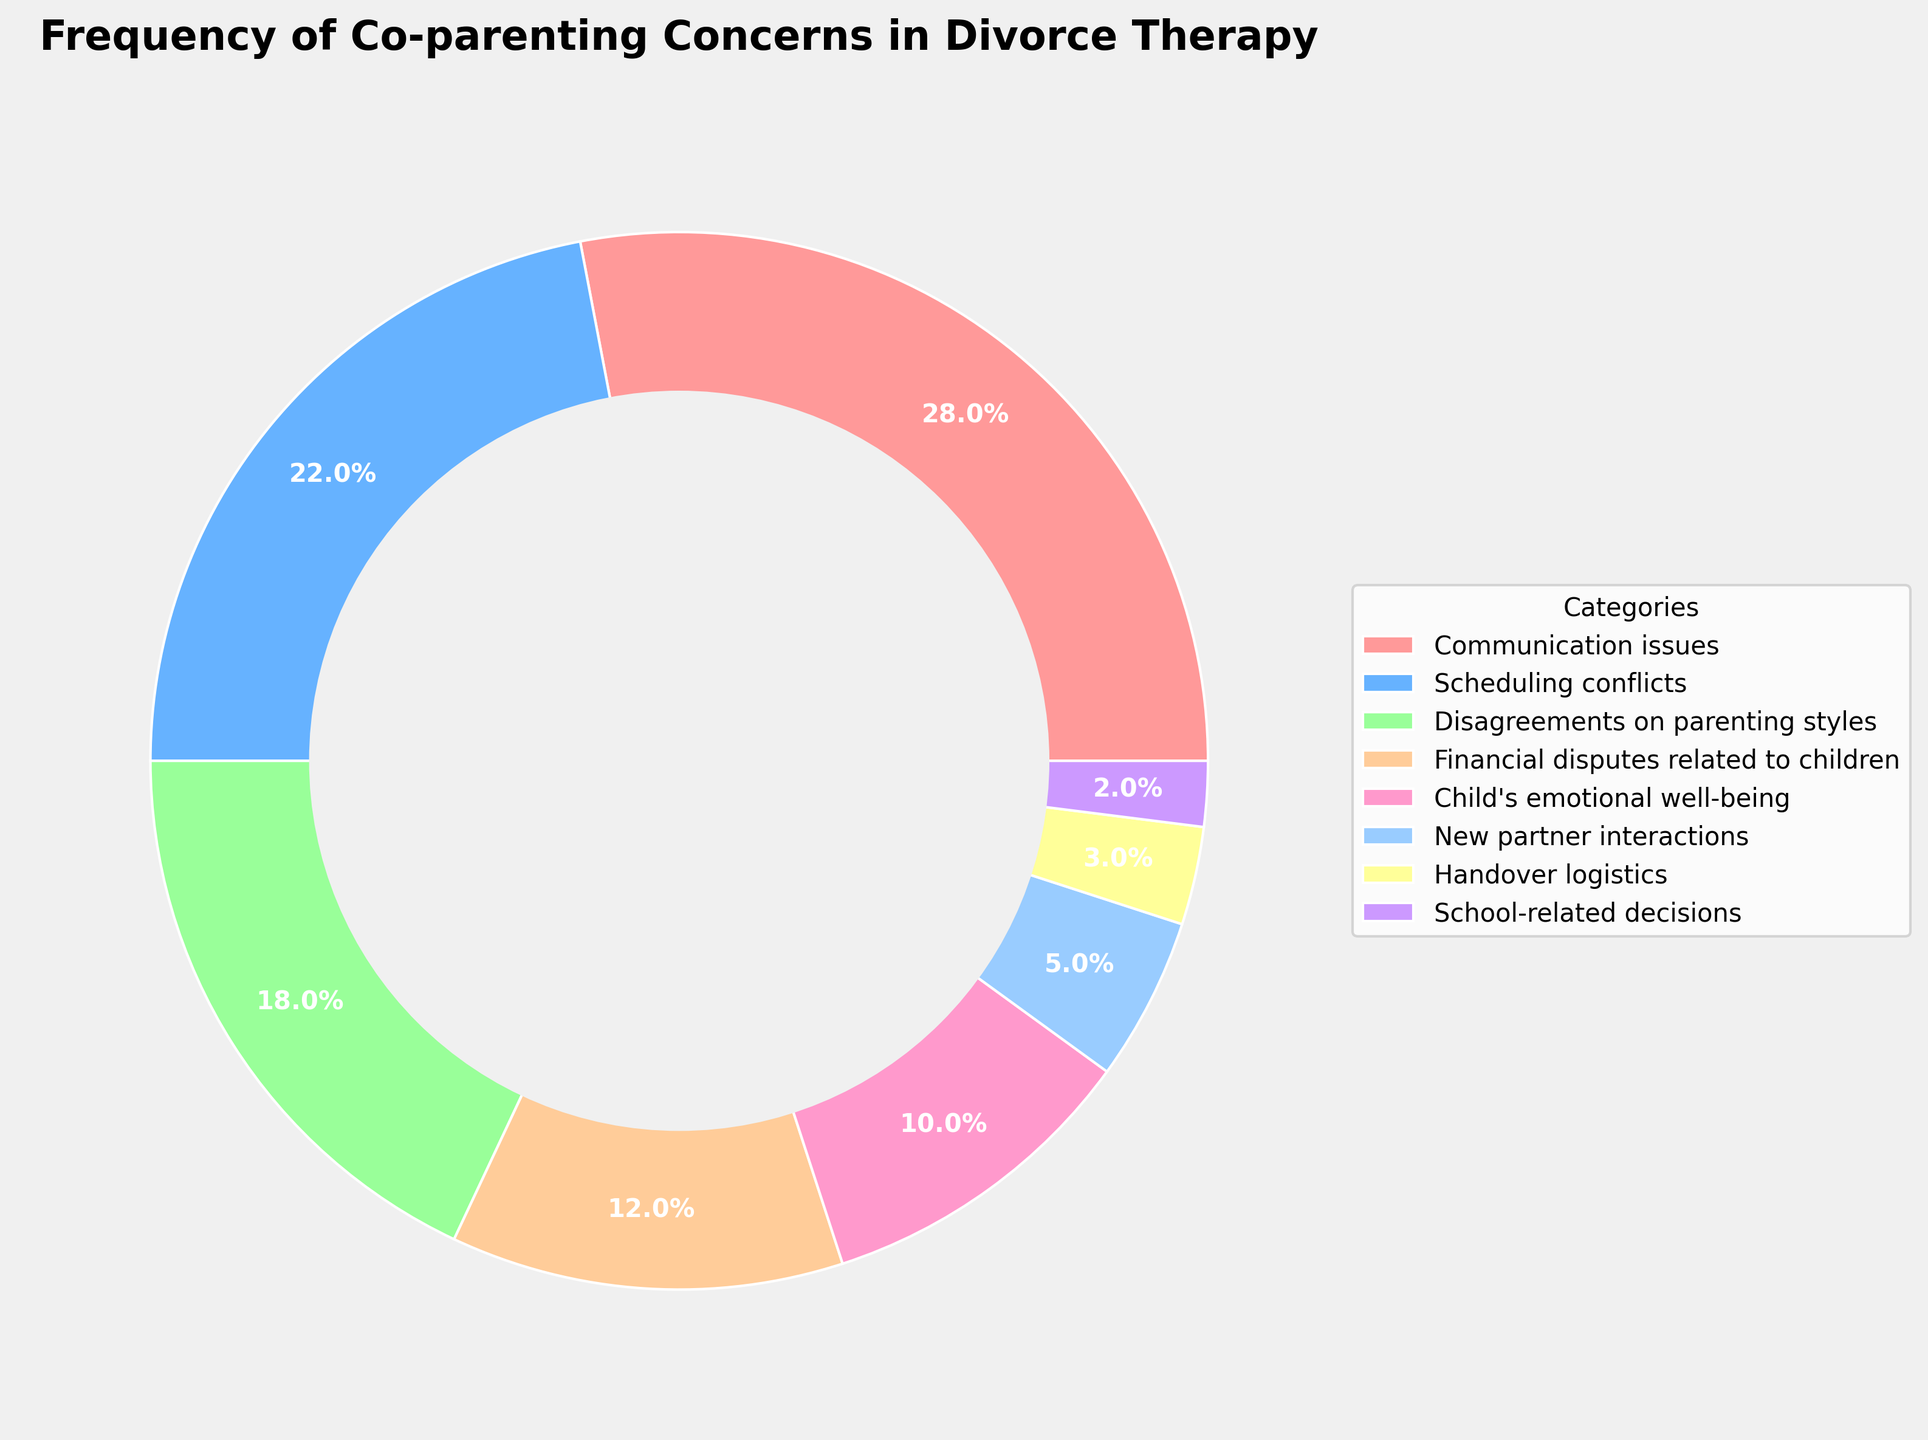What category represents the largest percentage of co-parenting concerns? By visually inspecting the pie chart, the segment representing "Communication issues" is the largest slice of the pie which signifies the highest percentage.
Answer: Communication issues What is the total percentage of concerns related to "Scheduling conflicts" and "Disagreements on parenting styles"? By adding the percentages of "Scheduling conflicts" (22%) and "Disagreements on parenting styles" (18%), we get 22 + 18 = 40.
Answer: 40% Which category has the smallest segment in the pie chart? Visually, the segment for "School-related decisions" is the smallest in the pie chart, indicating it has the least percentage.
Answer: School-related decisions Is the percentage of concerns about "Financial disputes related to children" greater than or less than concerns about "Child's emotional well-being"? By comparing the percentages, "Financial disputes related to children" is at 12%, while "Child's emotional well-being" is at 10%. Therefore, 12% is greater than 10%.
Answer: Greater than What is the sum of percentages for categories with values less than 10%? The categories with less than 10% are "New partner interactions" (5%), "Handover logistics" (3%), and "School-related decisions" (2%). Summing them gives 5 + 3 + 2 = 10.
Answer: 10% What categories together make up exactly 50% of the pie chart? Adding the percentages of "Communication issues" (28%) and "Scheduling conflicts" (22%) results in exactly 50%.
Answer: Communication issues and Scheduling conflicts How does the segment for "Communication issues" compare visually to the segment for "New partner interactions"? The segment for "Communication issues" is significantly larger than the segment for "New partner interactions", indicating a higher percentage of concerns related to communication issues.
Answer: Larger What is the average percentage of the three largest categories? The three largest categories are "Communication issues" (28%), "Scheduling conflicts" (22%), and "Disagreements on parenting styles" (18%). The average is calculated as (28 + 22 + 18) / 3 = 68 / 3 ≈ 22.67.
Answer: 22.67% By how much does the percentage of "Financial disputes related to children" exceed "Handover logistics"? Subtract the percentage of "Handover logistics" (3%) from that of "Financial disputes related to children" (12%), which gives 12 - 3 = 9.
Answer: 9% 